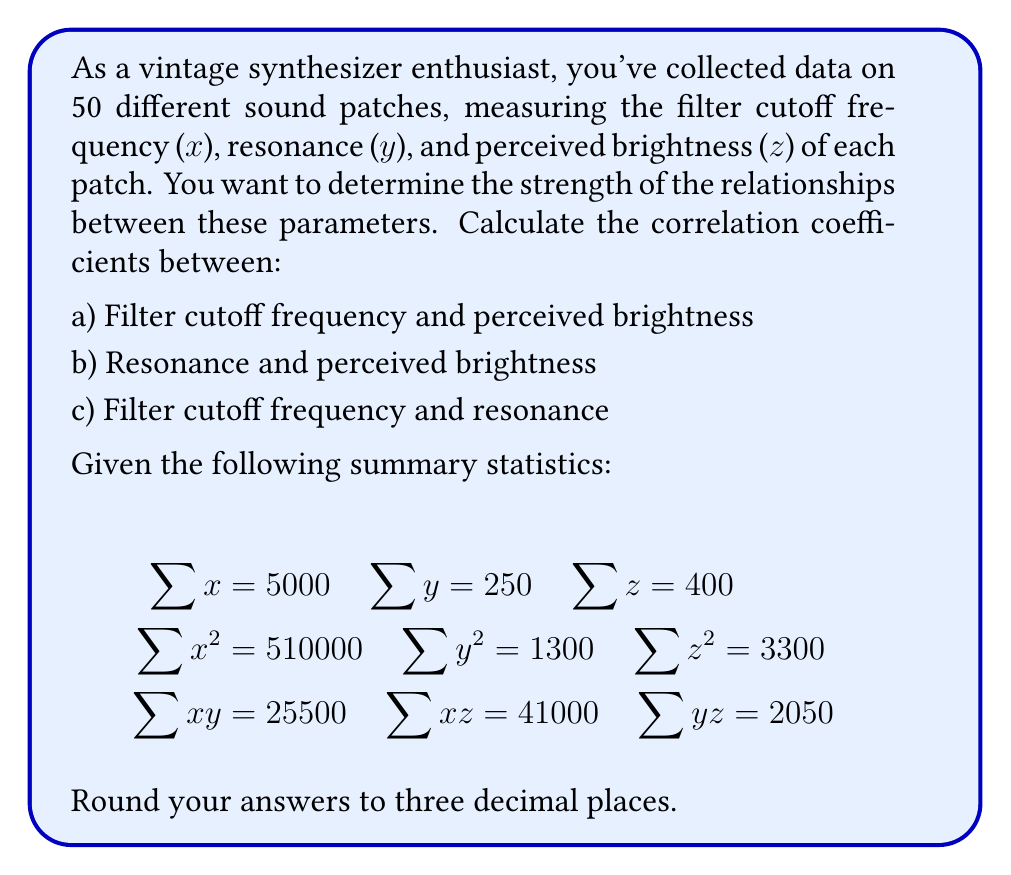Give your solution to this math problem. To calculate the correlation coefficients, we'll use the formula:

$$r_{xy} = \frac{n\sum xy - \sum x \sum y}{\sqrt{(n\sum x^2 - (\sum x)^2)(n\sum y^2 - (\sum y)^2)}}$$

Where n is the number of samples (50 in this case).

Step 1: Calculate $r_{xz}$ (Filter cutoff frequency and perceived brightness)

$$\begin{aligned}
r_{xz} &= \frac{50(41000) - (5000)(400)}{\sqrt{(50(510000) - 5000^2)(50(3300) - 400^2)}} \\
&= \frac{2050000 - 2000000}{\sqrt{(25500000 - 25000000)(165000 - 160000)}} \\
&= \frac{50000}{\sqrt{(500000)(5000)}} \\
&= \frac{50000}{\sqrt{2500000000}} \\
&= \frac{50000}{50000} = 1.000
\end{aligned}$$

Step 2: Calculate $r_{yz}$ (Resonance and perceived brightness)

$$\begin{aligned}
r_{yz} &= \frac{50(2050) - (250)(400)}{\sqrt{(50(1300) - 250^2)(50(3300) - 400^2)}} \\
&= \frac{102500 - 100000}{\sqrt{(65000 - 62500)(165000 - 160000)}} \\
&= \frac{2500}{\sqrt{(2500)(5000)}} \\
&= \frac{2500}{\sqrt{12500000}} \\
&= \frac{2500}{3535.534} = 0.707
\end{aligned}$$

Step 3: Calculate $r_{xy}$ (Filter cutoff frequency and resonance)

$$\begin{aligned}
r_{xy} &= \frac{50(25500) - (5000)(250)}{\sqrt{(50(510000) - 5000^2)(50(1300) - 250^2)}} \\
&= \frac{1275000 - 1250000}{\sqrt{(25500000 - 25000000)(65000 - 62500)}} \\
&= \frac{25000}{\sqrt{(500000)(2500)}} \\
&= \frac{25000}{\sqrt{1250000000}} \\
&= \frac{25000}{35355.339} = 0.707
\end{aligned}$$
Answer: a) 1.000
b) 0.707
c) 0.707 